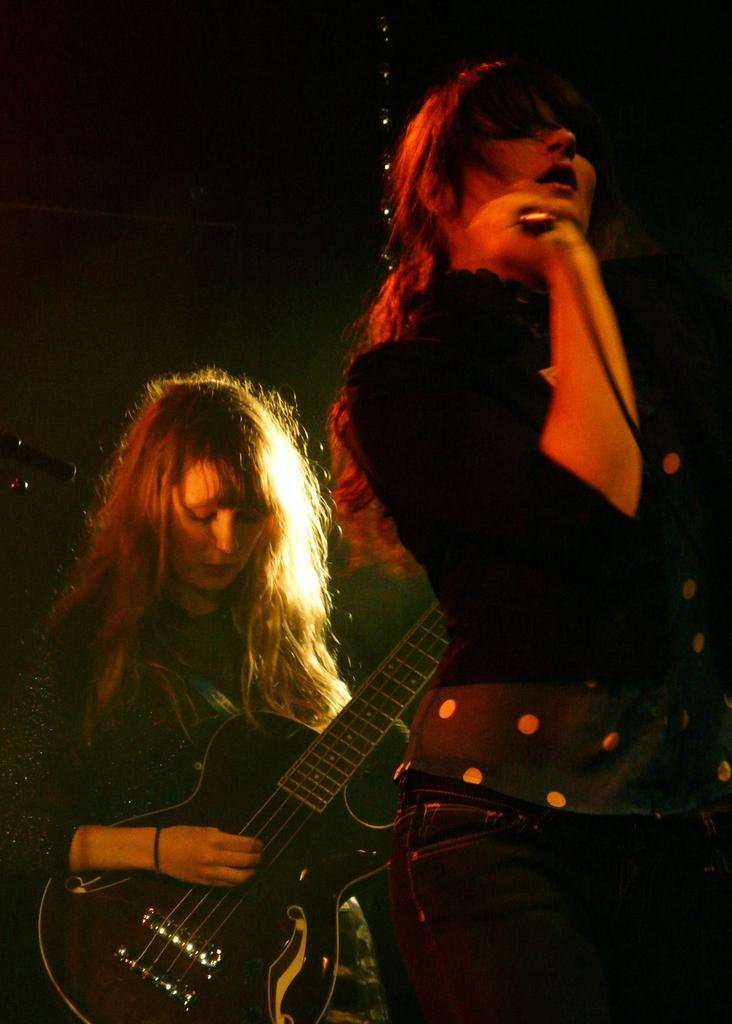What is the woman in the image doing? The woman in the image is playing a guitar. How is the woman holding the guitar? The woman is holding the guitar in her hands. What is the second woman in the image doing? The second woman is singing. What is the second woman holding in her hands? The second woman is holding a microphone in her hands. What type of committee can be seen in the image? There is no committee present in the image; it features two women, one playing a guitar and the other singing with a microphone. What is the woman in the front of the image doing? There is no reference to a "front" in the image, as it is a two-dimensional representation. 